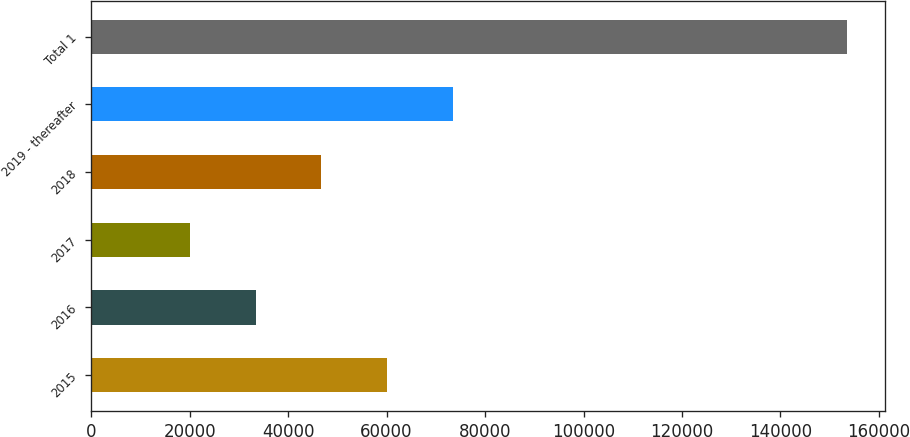Convert chart. <chart><loc_0><loc_0><loc_500><loc_500><bar_chart><fcel>2015<fcel>2016<fcel>2017<fcel>2018<fcel>2019 - thereafter<fcel>Total 1<nl><fcel>60084.7<fcel>33390.9<fcel>20044<fcel>46737.8<fcel>73431.6<fcel>153513<nl></chart> 